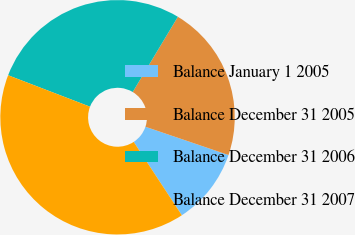Convert chart. <chart><loc_0><loc_0><loc_500><loc_500><pie_chart><fcel>Balance January 1 2005<fcel>Balance December 31 2005<fcel>Balance December 31 2006<fcel>Balance December 31 2007<nl><fcel>10.54%<fcel>21.61%<fcel>27.77%<fcel>40.07%<nl></chart> 